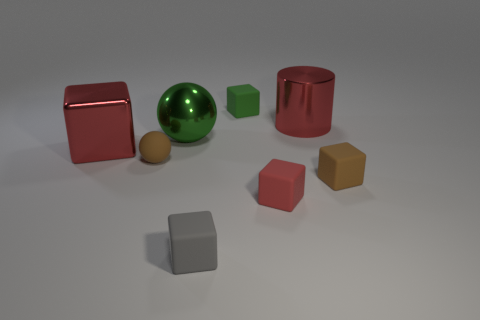Subtract 1 cubes. How many cubes are left? 4 Subtract all brown blocks. How many blocks are left? 4 Subtract all tiny gray blocks. How many blocks are left? 4 Subtract all blue cubes. Subtract all purple balls. How many cubes are left? 5 Add 1 brown rubber cubes. How many objects exist? 9 Subtract all cylinders. How many objects are left? 7 Subtract 0 blue spheres. How many objects are left? 8 Subtract all tiny brown balls. Subtract all small brown cubes. How many objects are left? 6 Add 4 tiny gray rubber cubes. How many tiny gray rubber cubes are left? 5 Add 1 small blue shiny balls. How many small blue shiny balls exist? 1 